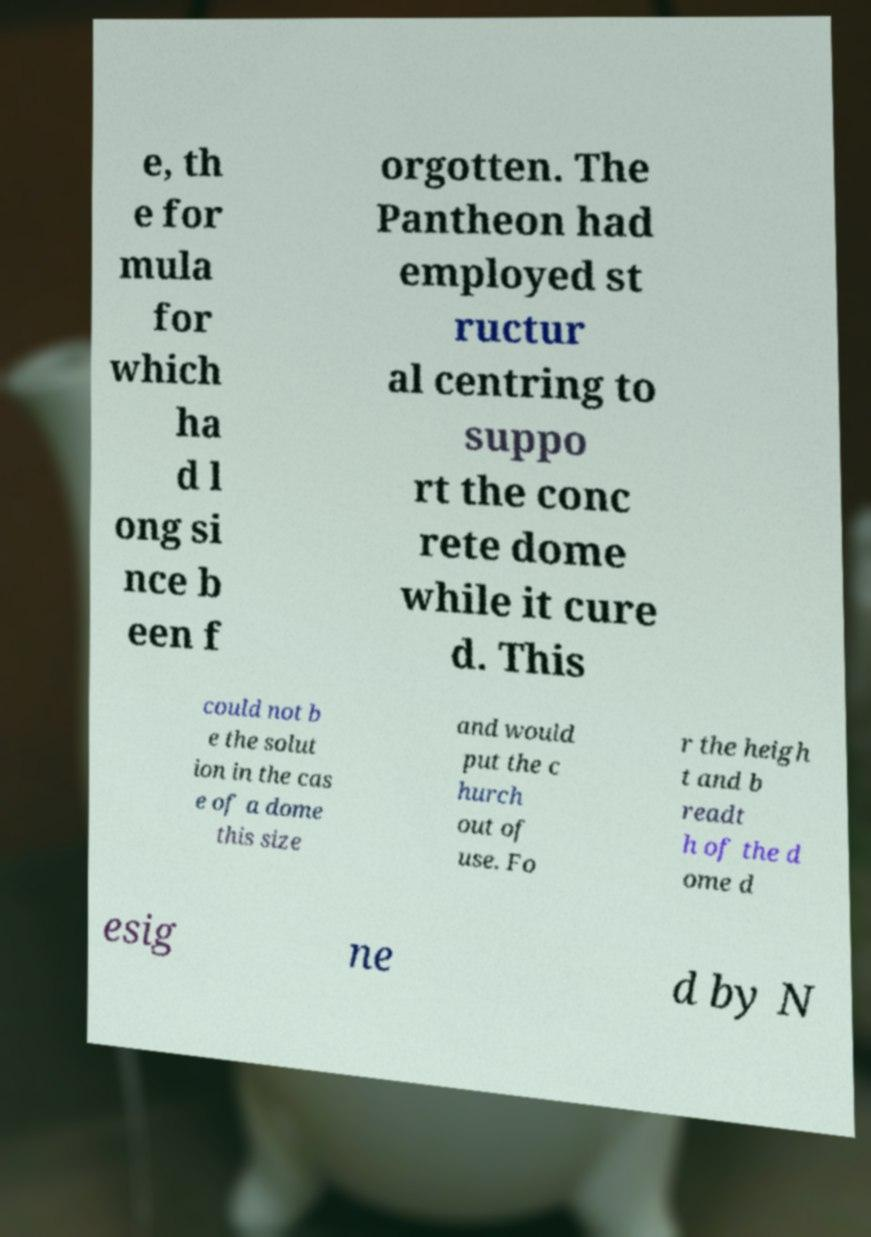Could you extract and type out the text from this image? e, th e for mula for which ha d l ong si nce b een f orgotten. The Pantheon had employed st ructur al centring to suppo rt the conc rete dome while it cure d. This could not b e the solut ion in the cas e of a dome this size and would put the c hurch out of use. Fo r the heigh t and b readt h of the d ome d esig ne d by N 